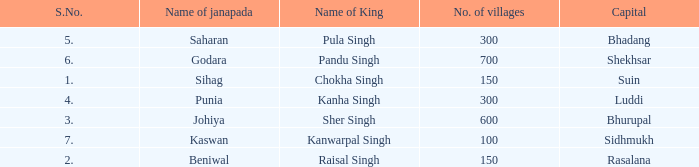What is the average number of villages with a name of janapada of Punia? 300.0. 